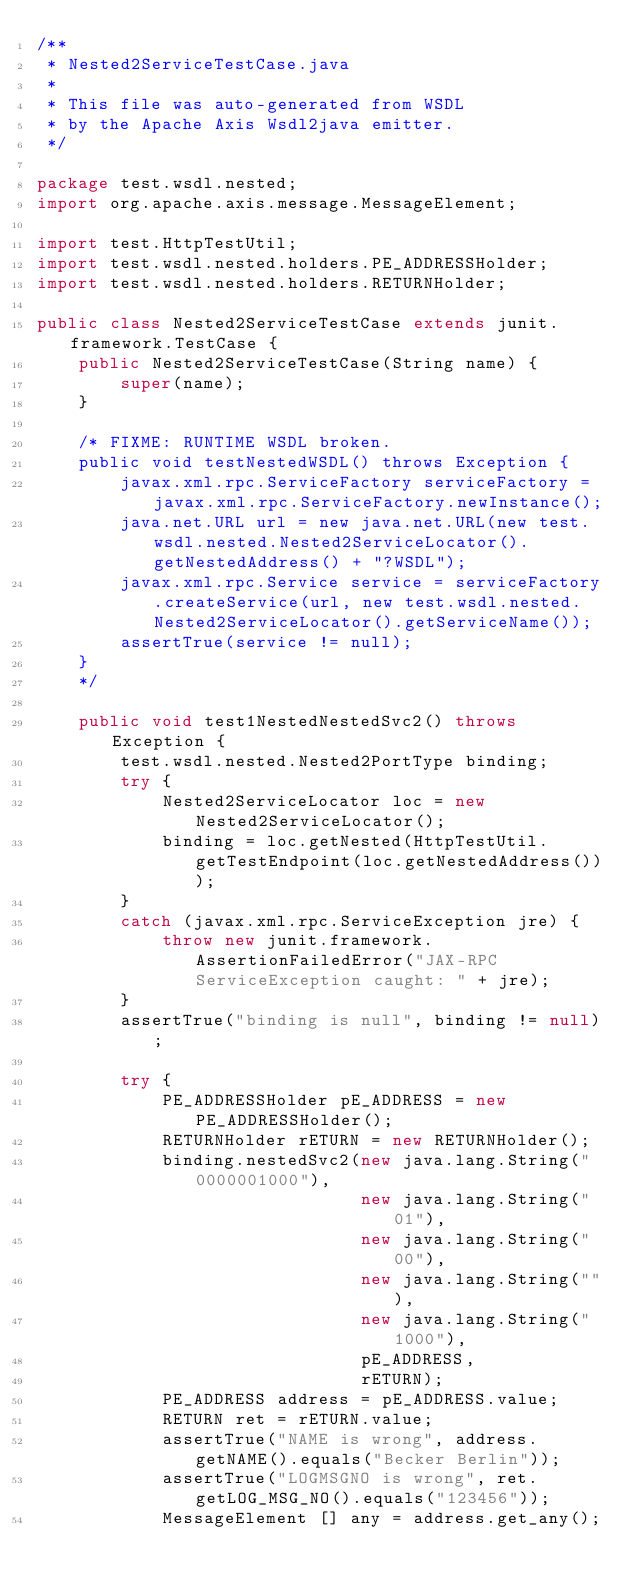Convert code to text. <code><loc_0><loc_0><loc_500><loc_500><_Java_>/**
 * Nested2ServiceTestCase.java
 *
 * This file was auto-generated from WSDL
 * by the Apache Axis Wsdl2java emitter.
 */

package test.wsdl.nested;
import org.apache.axis.message.MessageElement;

import test.HttpTestUtil;
import test.wsdl.nested.holders.PE_ADDRESSHolder;
import test.wsdl.nested.holders.RETURNHolder;

public class Nested2ServiceTestCase extends junit.framework.TestCase {
    public Nested2ServiceTestCase(String name) {
        super(name);
    }

    /* FIXME: RUNTIME WSDL broken.
    public void testNestedWSDL() throws Exception {
        javax.xml.rpc.ServiceFactory serviceFactory = javax.xml.rpc.ServiceFactory.newInstance();
        java.net.URL url = new java.net.URL(new test.wsdl.nested.Nested2ServiceLocator().getNestedAddress() + "?WSDL");
        javax.xml.rpc.Service service = serviceFactory.createService(url, new test.wsdl.nested.Nested2ServiceLocator().getServiceName());
        assertTrue(service != null);
    }
    */

    public void test1NestedNestedSvc2() throws Exception {
        test.wsdl.nested.Nested2PortType binding;
        try {
            Nested2ServiceLocator loc = new Nested2ServiceLocator();
            binding = loc.getNested(HttpTestUtil.getTestEndpoint(loc.getNestedAddress()));
        }
        catch (javax.xml.rpc.ServiceException jre) {
            throw new junit.framework.AssertionFailedError("JAX-RPC ServiceException caught: " + jre);
        }
        assertTrue("binding is null", binding != null);

        try {
            PE_ADDRESSHolder pE_ADDRESS = new PE_ADDRESSHolder();
            RETURNHolder rETURN = new RETURNHolder();
            binding.nestedSvc2(new java.lang.String("0000001000"),
                               new java.lang.String("01"),
                               new java.lang.String("00"),
                               new java.lang.String(""),
                               new java.lang.String("1000"),
                               pE_ADDRESS,
                               rETURN);
            PE_ADDRESS address = pE_ADDRESS.value;
            RETURN ret = rETURN.value;
            assertTrue("NAME is wrong", address.getNAME().equals("Becker Berlin"));
            assertTrue("LOGMSGNO is wrong", ret.getLOG_MSG_NO().equals("123456"));
            MessageElement [] any = address.get_any();</code> 